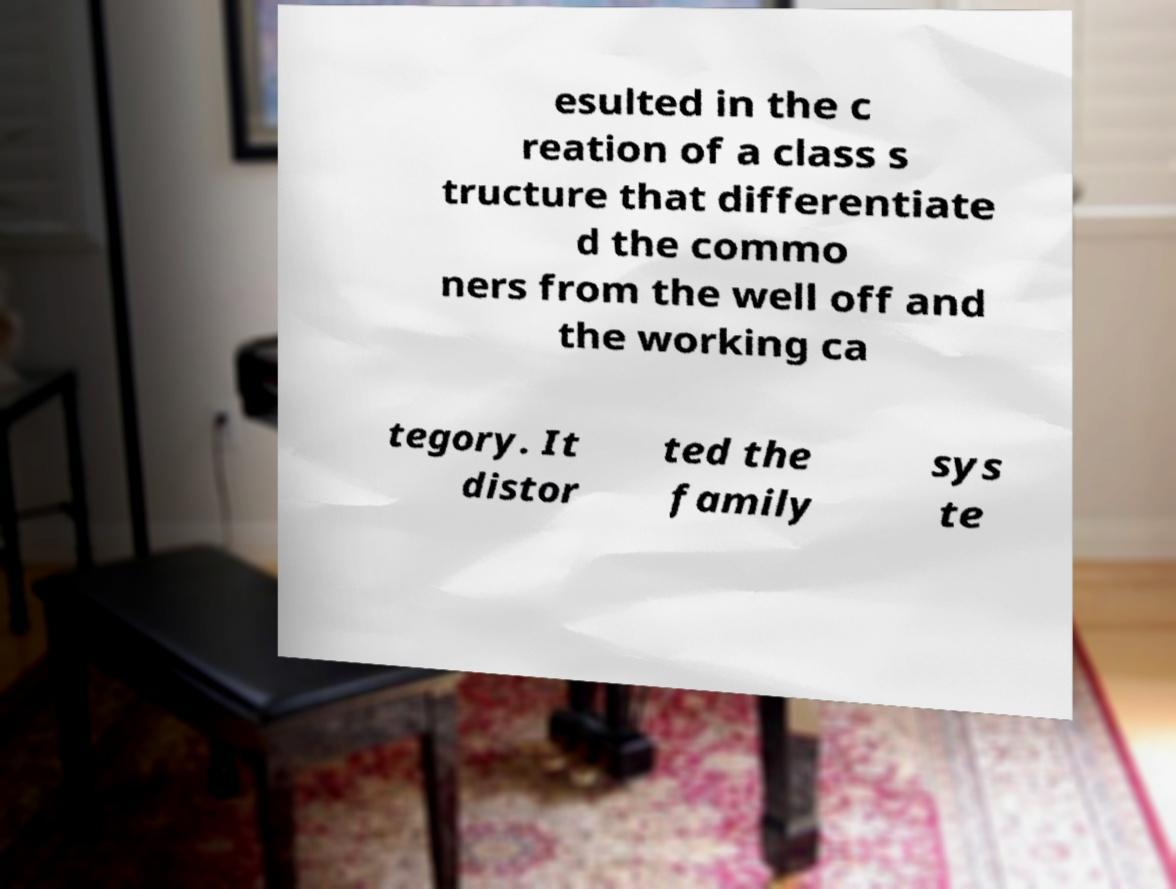I need the written content from this picture converted into text. Can you do that? esulted in the c reation of a class s tructure that differentiate d the commo ners from the well off and the working ca tegory. It distor ted the family sys te 